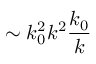Convert formula to latex. <formula><loc_0><loc_0><loc_500><loc_500>\sim k _ { 0 } ^ { 2 } k ^ { 2 } \frac { k _ { 0 } } { k }</formula> 